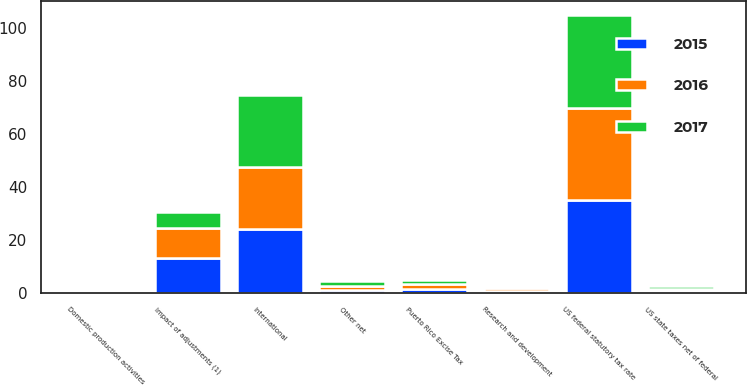Convert chart. <chart><loc_0><loc_0><loc_500><loc_500><stacked_bar_chart><ecel><fcel>US federal statutory tax rate<fcel>US state taxes net of federal<fcel>Research and development<fcel>Domestic production activities<fcel>International<fcel>Puerto Rico Excise Tax<fcel>Impact of adjustments (1)<fcel>Other net<nl><fcel>2017<fcel>35<fcel>1<fcel>0.9<fcel>0.4<fcel>27.1<fcel>1.5<fcel>5.7<fcel>1.8<nl><fcel>2016<fcel>35<fcel>0.9<fcel>1.2<fcel>0.3<fcel>23.4<fcel>1.6<fcel>11.4<fcel>1.5<nl><fcel>2015<fcel>35<fcel>0.8<fcel>0.7<fcel>0.4<fcel>24.3<fcel>1.7<fcel>13.3<fcel>1.3<nl></chart> 